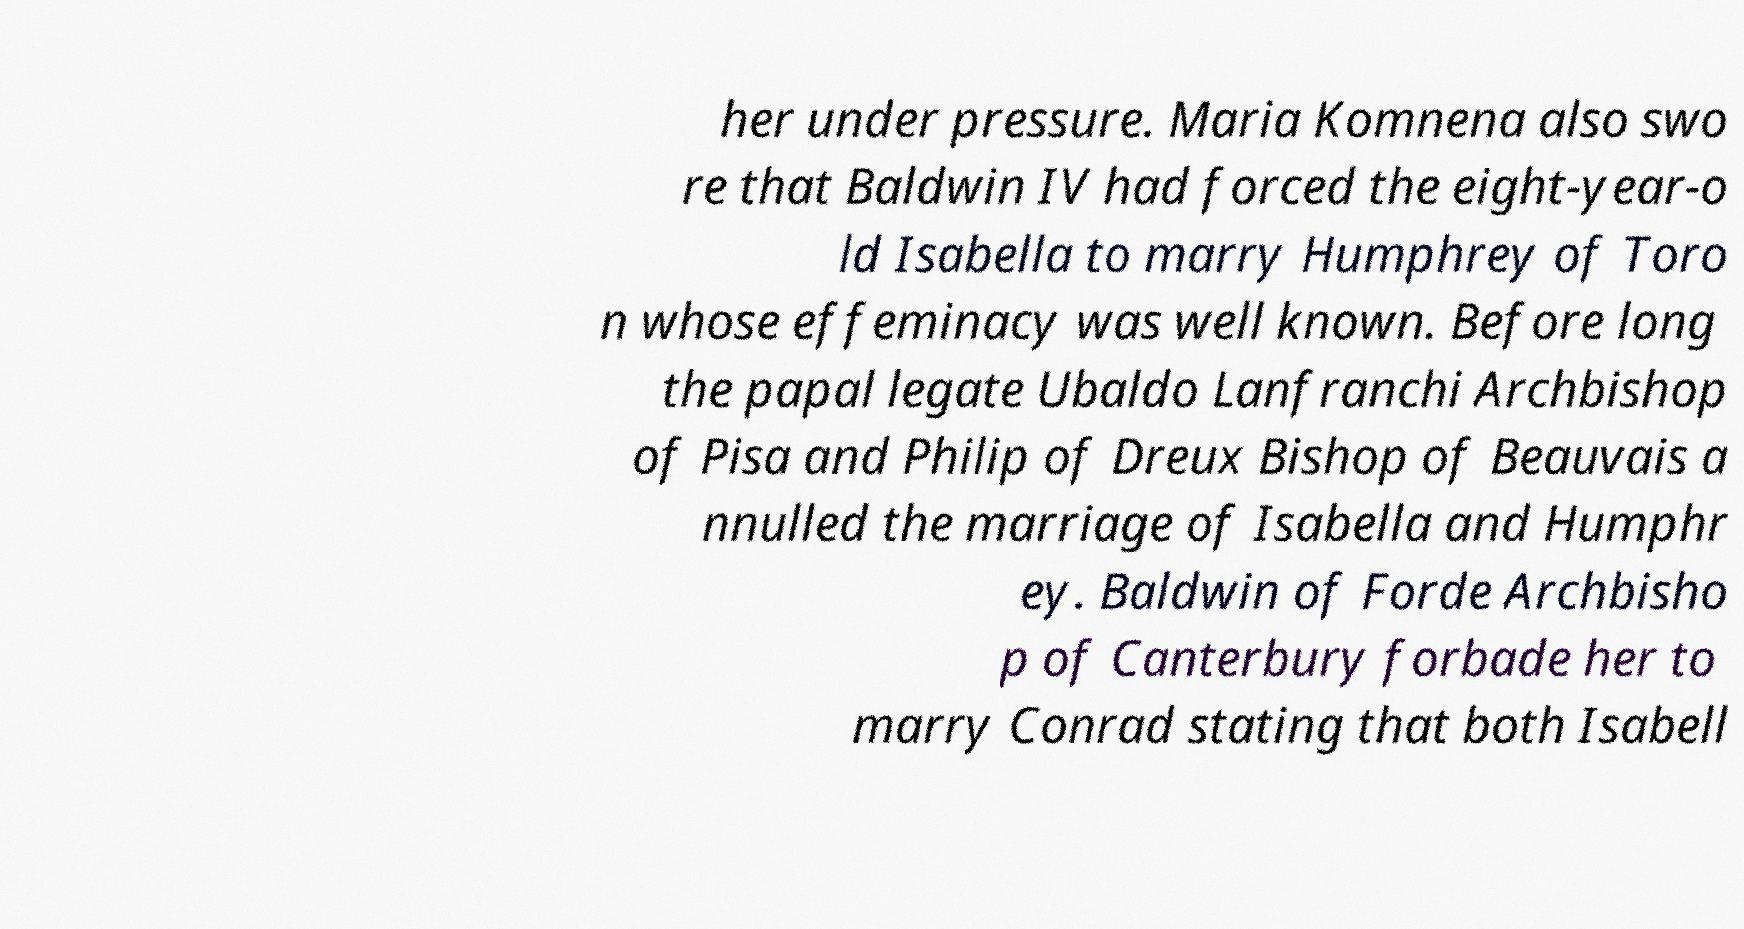There's text embedded in this image that I need extracted. Can you transcribe it verbatim? her under pressure. Maria Komnena also swo re that Baldwin IV had forced the eight-year-o ld Isabella to marry Humphrey of Toro n whose effeminacy was well known. Before long the papal legate Ubaldo Lanfranchi Archbishop of Pisa and Philip of Dreux Bishop of Beauvais a nnulled the marriage of Isabella and Humphr ey. Baldwin of Forde Archbisho p of Canterbury forbade her to marry Conrad stating that both Isabell 